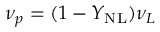Convert formula to latex. <formula><loc_0><loc_0><loc_500><loc_500>\nu _ { p } = ( 1 - Y _ { N L } ) \nu _ { L }</formula> 